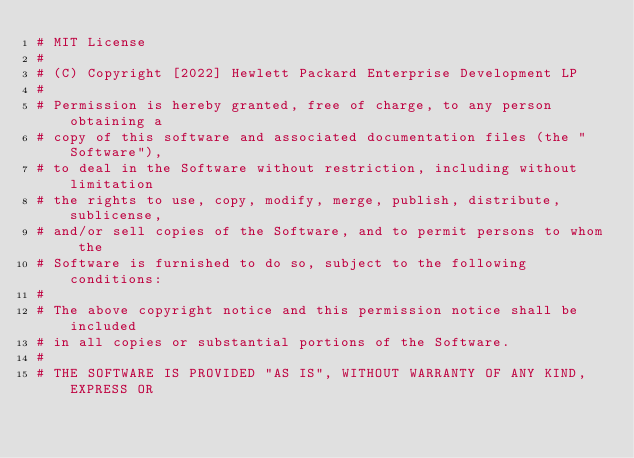<code> <loc_0><loc_0><loc_500><loc_500><_Python_># MIT License
#
# (C) Copyright [2022] Hewlett Packard Enterprise Development LP
#
# Permission is hereby granted, free of charge, to any person obtaining a
# copy of this software and associated documentation files (the "Software"),
# to deal in the Software without restriction, including without limitation
# the rights to use, copy, modify, merge, publish, distribute, sublicense,
# and/or sell copies of the Software, and to permit persons to whom the
# Software is furnished to do so, subject to the following conditions:
#
# The above copyright notice and this permission notice shall be included
# in all copies or substantial portions of the Software.
#
# THE SOFTWARE IS PROVIDED "AS IS", WITHOUT WARRANTY OF ANY KIND, EXPRESS OR</code> 